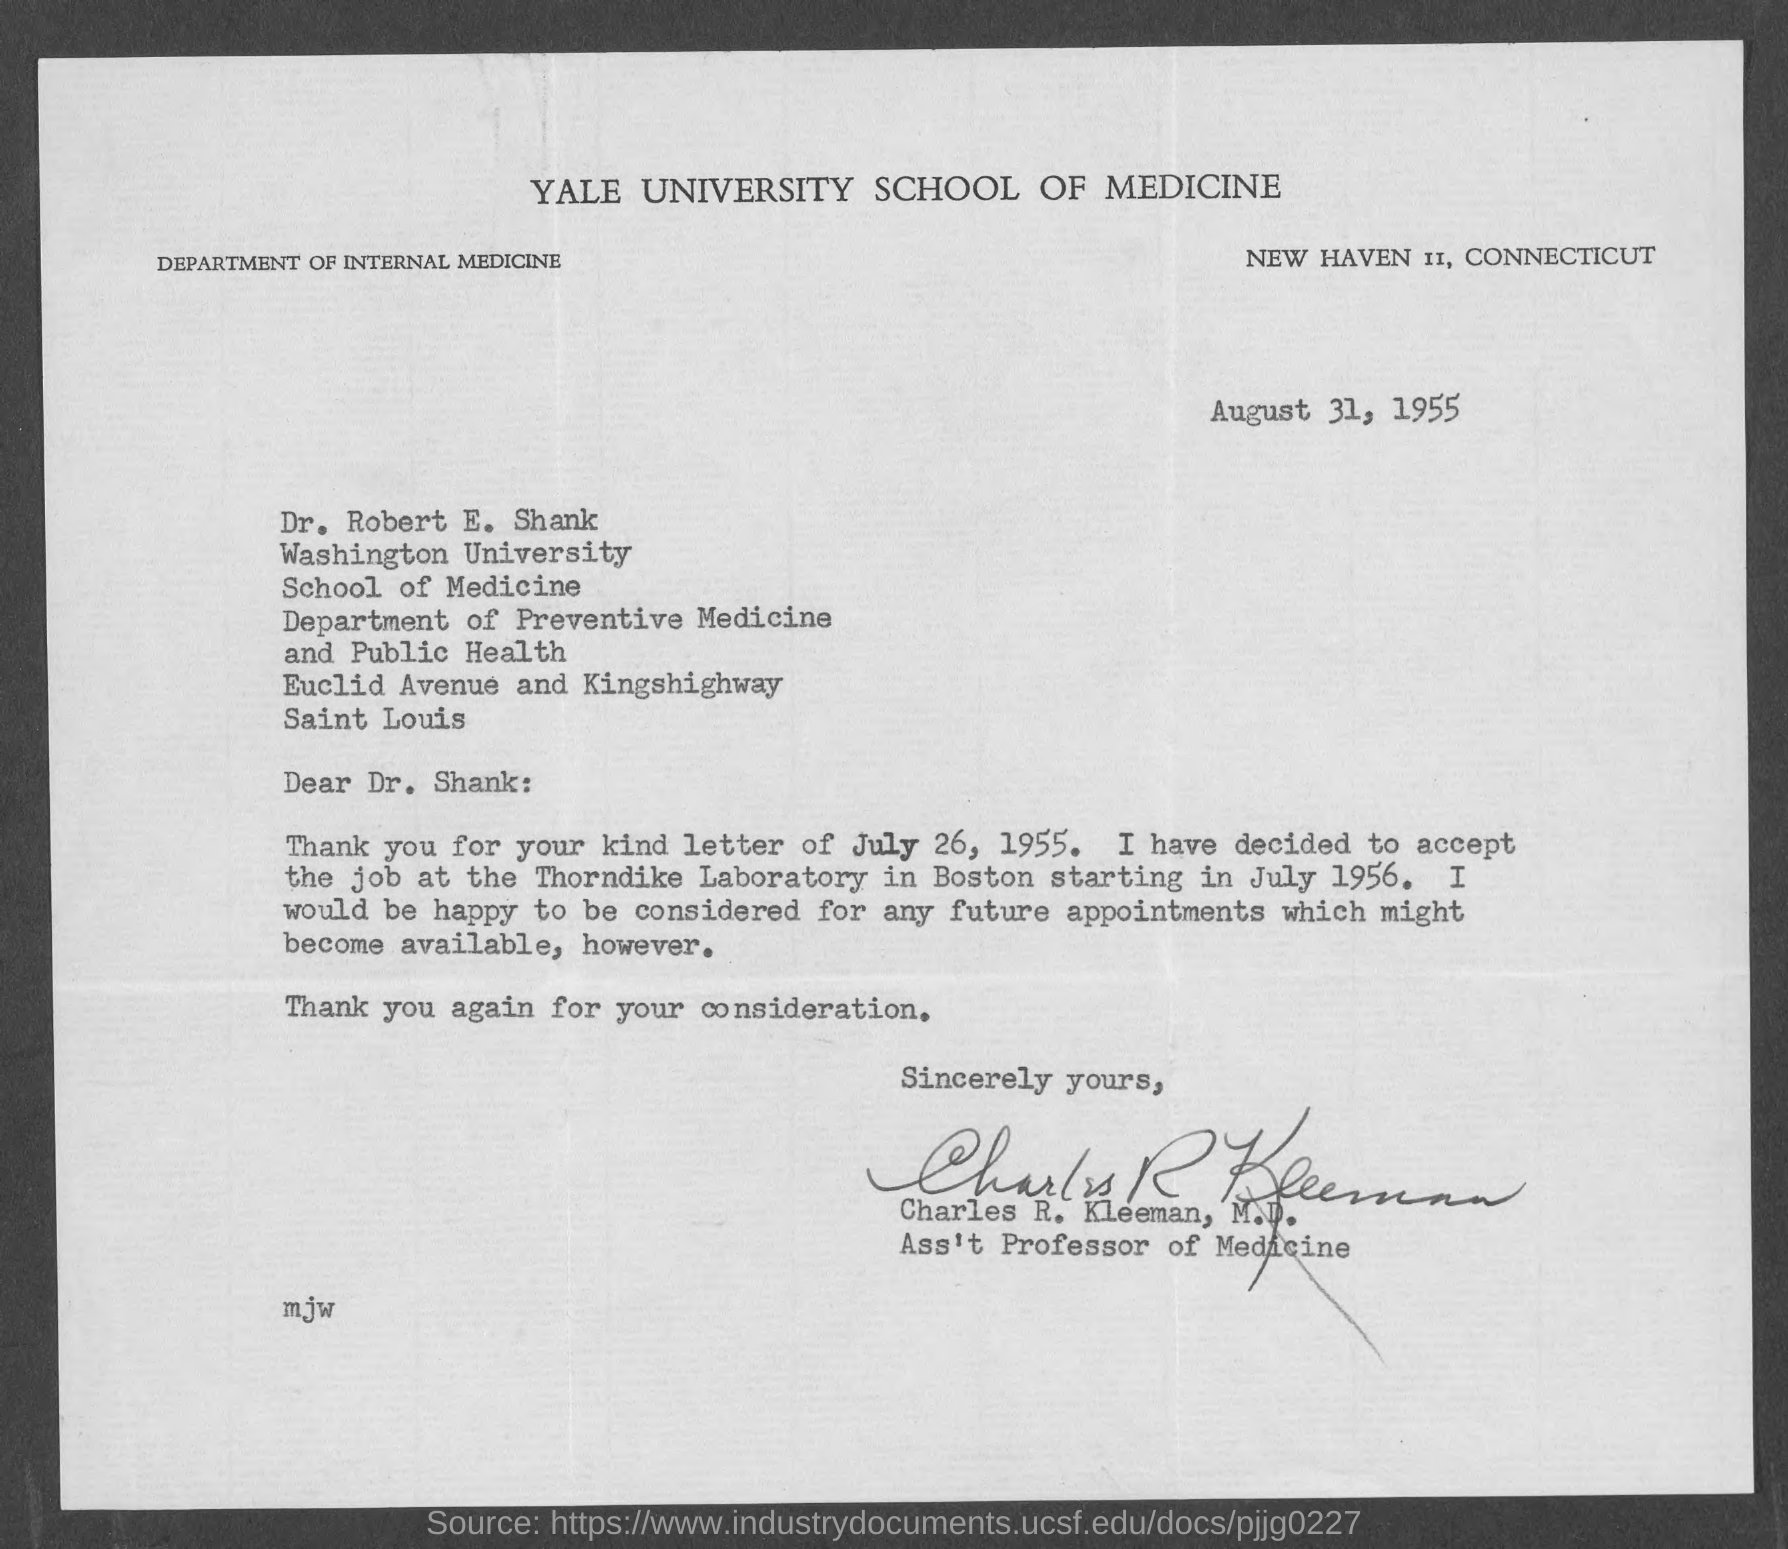What is the date mentioned ?
Keep it short and to the point. AUGUST 31, 1955. To whom this letter is written ?
Your answer should be compact. Dr. Shank. To which university Dr. Robert  E. Shank belongs to ?
Offer a very short reply. Washington university. This letter is written by whom ?
Offer a very short reply. CHARLES R. KLEEMAN. On which date he decided to accept the job at the thorndike laboratory in boston ?
Ensure brevity in your answer.  July 1956. Who is the ass't professor of medicine at yale university
Your answer should be compact. CHARLES R. KLEEMAN. Where is yale university  school of medicine located ?
Your answer should be compact. New Haven  II , Connecticut. 